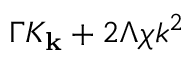Convert formula to latex. <formula><loc_0><loc_0><loc_500><loc_500>\Gamma K _ { k } + 2 \Lambda \chi k ^ { 2 }</formula> 